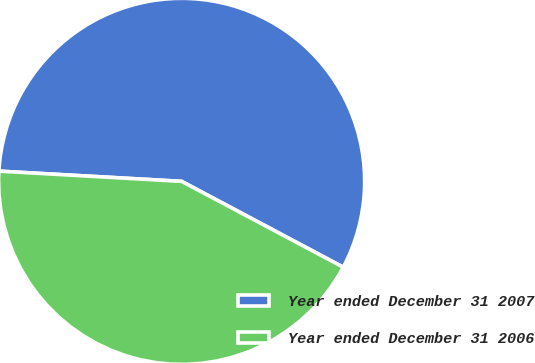Convert chart to OTSL. <chart><loc_0><loc_0><loc_500><loc_500><pie_chart><fcel>Year ended December 31 2007<fcel>Year ended December 31 2006<nl><fcel>56.88%<fcel>43.12%<nl></chart> 